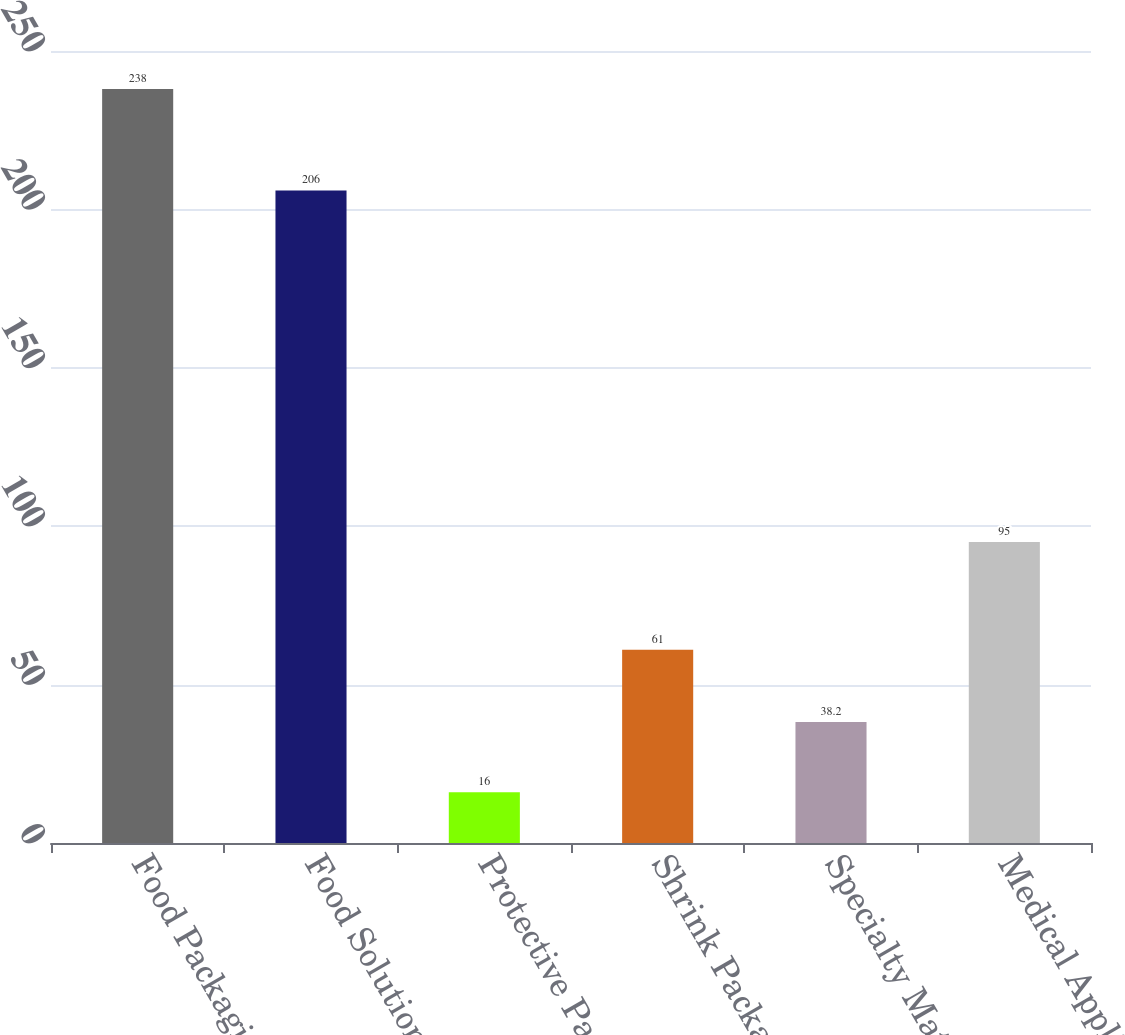Convert chart. <chart><loc_0><loc_0><loc_500><loc_500><bar_chart><fcel>Food Packaging<fcel>Food Solutions<fcel>Protective Packaging<fcel>Shrink Packaging<fcel>Specialty Materials<fcel>Medical Applications<nl><fcel>238<fcel>206<fcel>16<fcel>61<fcel>38.2<fcel>95<nl></chart> 